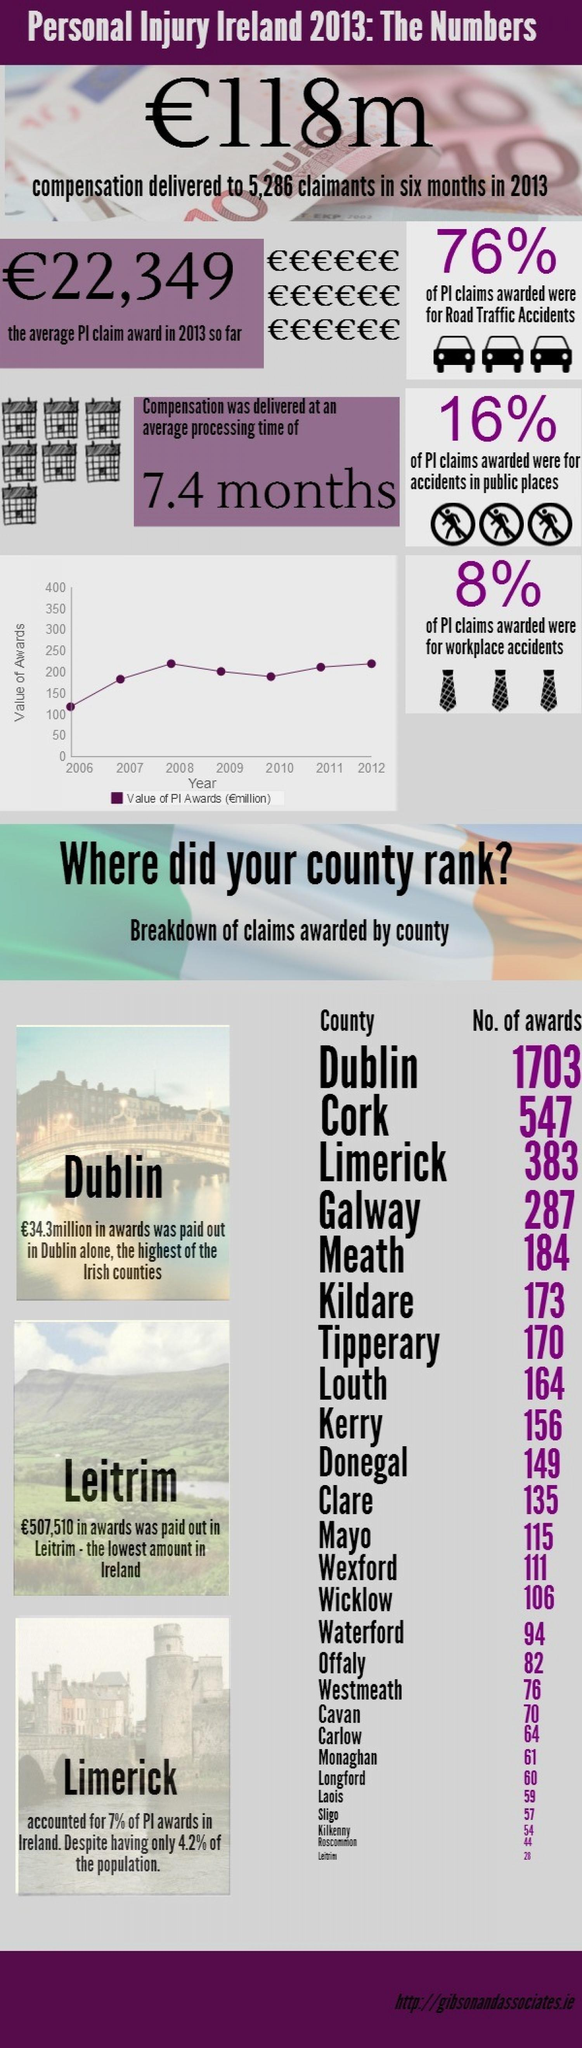Highlight a few significant elements in this photo. In 2013, the most personal injury claims awarded for were a result of road traffic accidents, with a total of [insert amount of claims awarded here]. In 2017, Dublin was awarded a total of 1703 awards, with each award amounting to €34.3 million in euros. Clare awarded more awards than Offaly, with a difference of 53 awards. Donegal County in Ireland placed tenth in awarding the highest number of claims. Dublin received more awards than Kildare, with a difference of 1,530. 